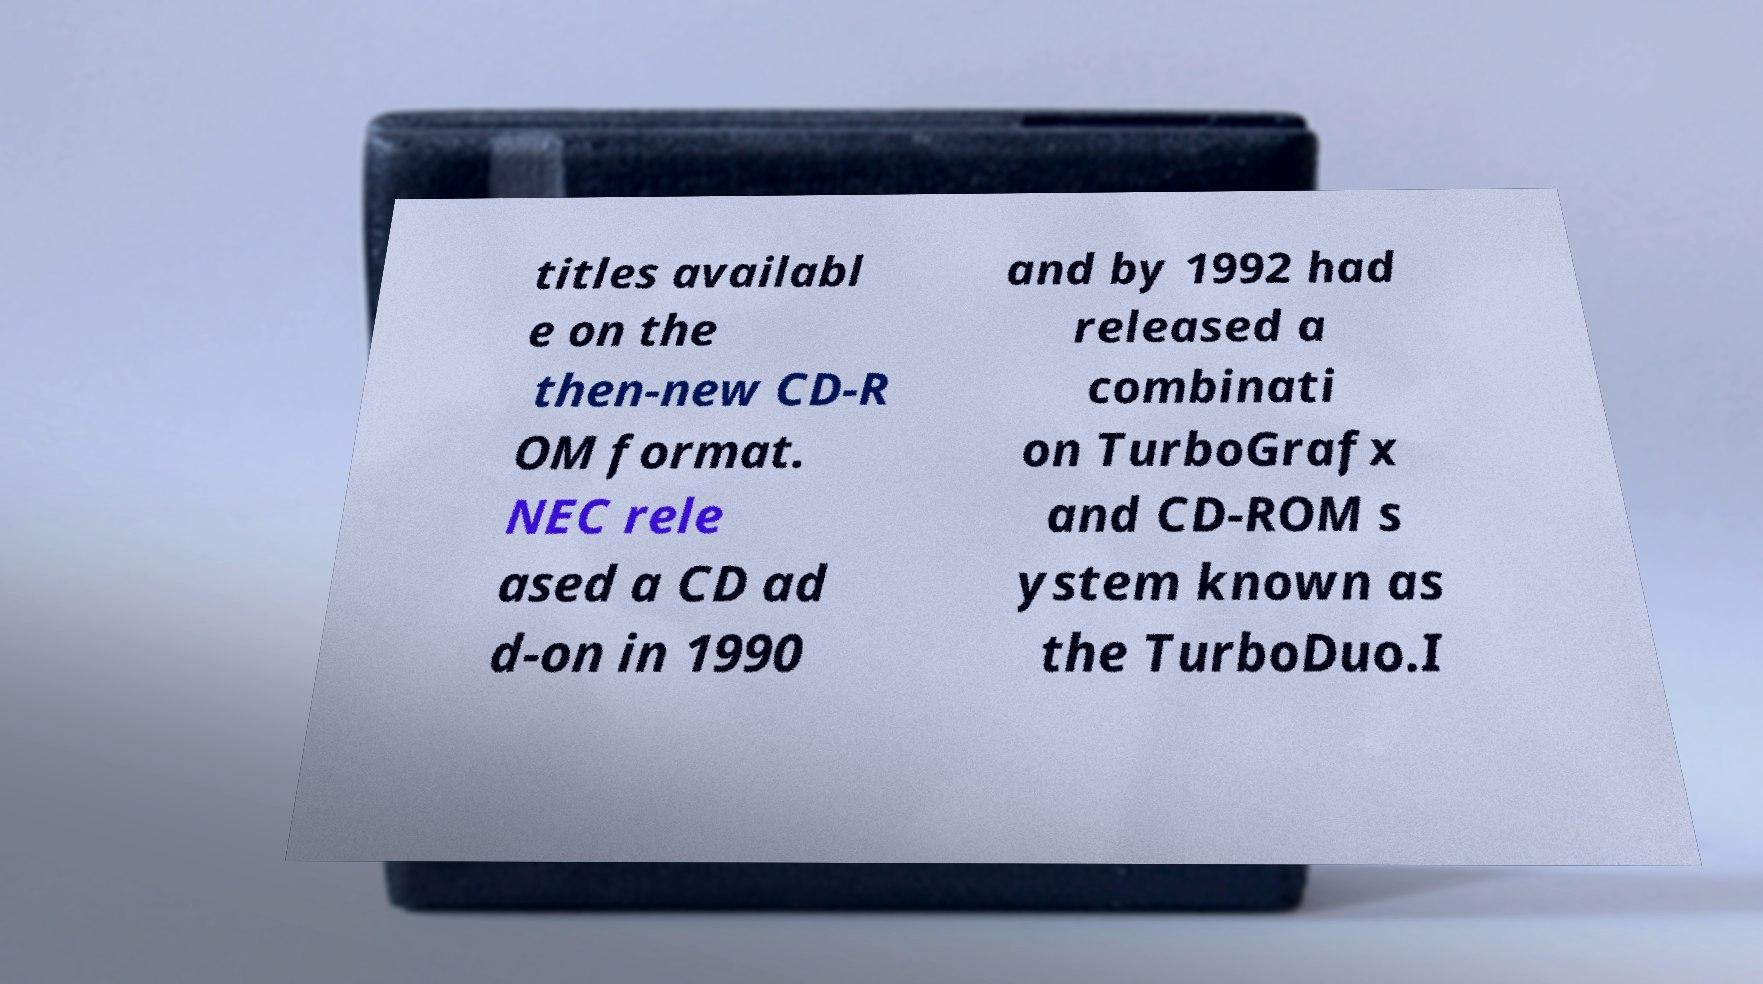Could you assist in decoding the text presented in this image and type it out clearly? titles availabl e on the then-new CD-R OM format. NEC rele ased a CD ad d-on in 1990 and by 1992 had released a combinati on TurboGrafx and CD-ROM s ystem known as the TurboDuo.I 